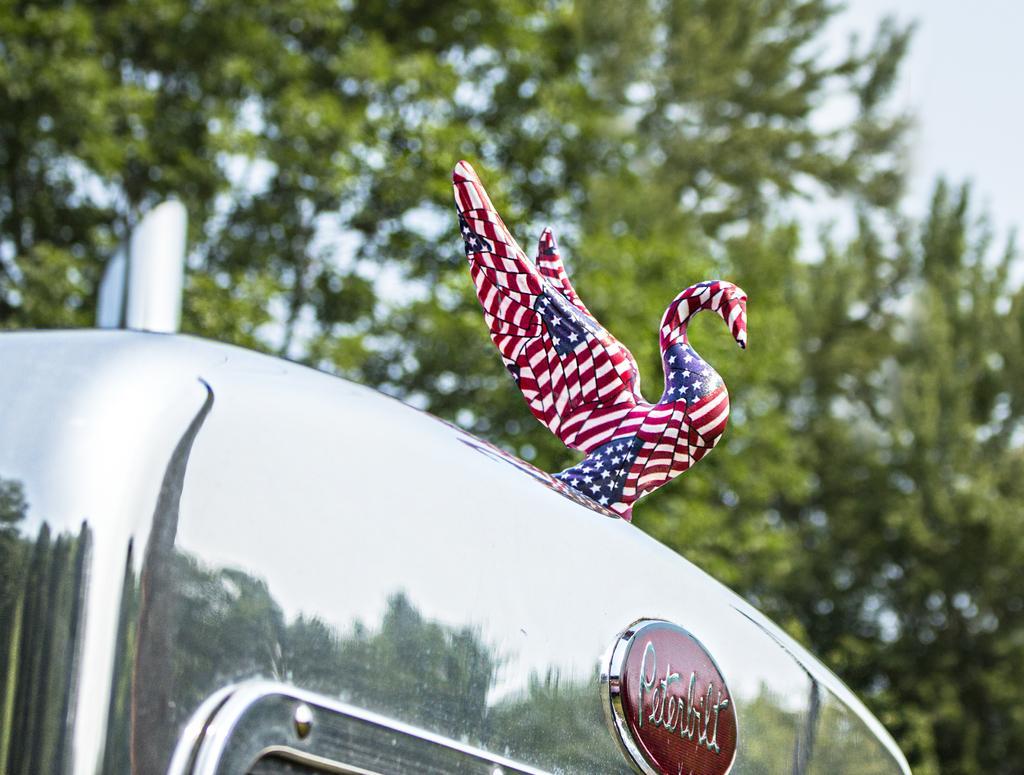In one or two sentences, can you explain what this image depicts? In the image in the center, we can see one vehicle. On the vehicle, there is a banner and one bird sign, which is in red and blue color. In the background we can see the sky, clouds and trees. 